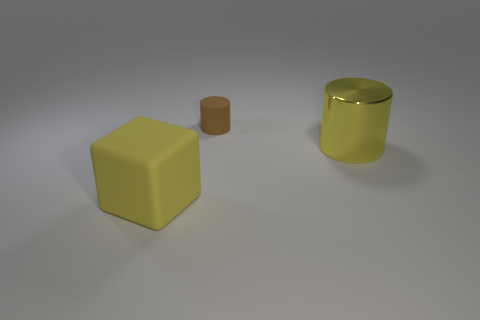What number of objects are either yellow things that are on the right side of the rubber block or yellow objects that are in front of the yellow shiny object?
Keep it short and to the point. 2. Is the big rubber thing the same color as the large cylinder?
Provide a succinct answer. Yes. Are there fewer rubber cylinders than brown balls?
Make the answer very short. No. There is a large cylinder; are there any yellow cylinders behind it?
Provide a short and direct response. No. Is the material of the big yellow cylinder the same as the small cylinder?
Ensure brevity in your answer.  No. There is a large metal object that is the same shape as the brown rubber thing; what is its color?
Keep it short and to the point. Yellow. There is a cylinder on the left side of the large cylinder; does it have the same color as the rubber cube?
Offer a very short reply. No. There is a big shiny thing that is the same color as the rubber block; what shape is it?
Ensure brevity in your answer.  Cylinder. What number of brown cylinders have the same material as the small brown thing?
Provide a succinct answer. 0. There is a tiny brown cylinder; what number of rubber cubes are behind it?
Your response must be concise. 0. 